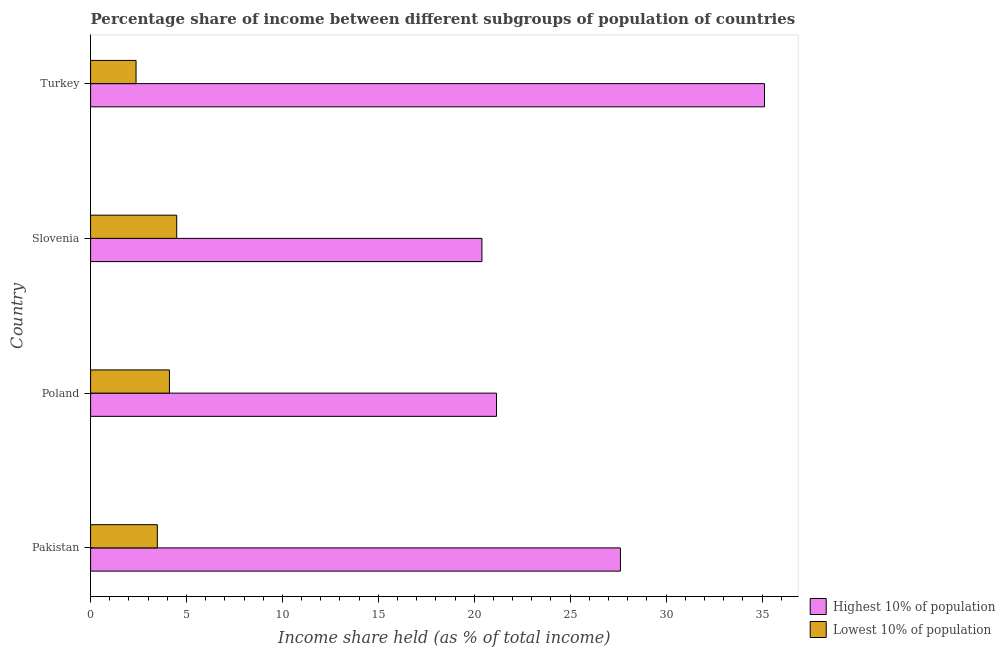How many different coloured bars are there?
Your response must be concise. 2. How many groups of bars are there?
Provide a succinct answer. 4. Are the number of bars per tick equal to the number of legend labels?
Provide a succinct answer. Yes. Are the number of bars on each tick of the Y-axis equal?
Your answer should be very brief. Yes. What is the label of the 1st group of bars from the top?
Your answer should be compact. Turkey. What is the income share held by highest 10% of the population in Slovenia?
Provide a short and direct response. 20.4. Across all countries, what is the maximum income share held by lowest 10% of the population?
Your answer should be very brief. 4.49. Across all countries, what is the minimum income share held by highest 10% of the population?
Give a very brief answer. 20.4. In which country was the income share held by highest 10% of the population minimum?
Your answer should be compact. Slovenia. What is the total income share held by lowest 10% of the population in the graph?
Your answer should be very brief. 14.45. What is the difference between the income share held by highest 10% of the population in Poland and that in Slovenia?
Your response must be concise. 0.76. What is the difference between the income share held by lowest 10% of the population in Slovenia and the income share held by highest 10% of the population in Poland?
Offer a terse response. -16.67. What is the average income share held by lowest 10% of the population per country?
Offer a terse response. 3.61. What is the difference between the income share held by lowest 10% of the population and income share held by highest 10% of the population in Slovenia?
Provide a succinct answer. -15.91. In how many countries, is the income share held by lowest 10% of the population greater than 26 %?
Make the answer very short. 0. What is the ratio of the income share held by highest 10% of the population in Pakistan to that in Slovenia?
Your answer should be very brief. 1.35. Is the income share held by highest 10% of the population in Poland less than that in Slovenia?
Provide a succinct answer. No. What is the difference between the highest and the second highest income share held by highest 10% of the population?
Keep it short and to the point. 7.51. What is the difference between the highest and the lowest income share held by highest 10% of the population?
Offer a terse response. 14.73. In how many countries, is the income share held by highest 10% of the population greater than the average income share held by highest 10% of the population taken over all countries?
Your response must be concise. 2. Is the sum of the income share held by highest 10% of the population in Slovenia and Turkey greater than the maximum income share held by lowest 10% of the population across all countries?
Offer a terse response. Yes. What does the 1st bar from the top in Poland represents?
Ensure brevity in your answer.  Lowest 10% of population. What does the 1st bar from the bottom in Turkey represents?
Give a very brief answer. Highest 10% of population. How many bars are there?
Keep it short and to the point. 8. Are all the bars in the graph horizontal?
Provide a succinct answer. Yes. How many countries are there in the graph?
Offer a very short reply. 4. Are the values on the major ticks of X-axis written in scientific E-notation?
Make the answer very short. No. Does the graph contain any zero values?
Give a very brief answer. No. Where does the legend appear in the graph?
Your response must be concise. Bottom right. How many legend labels are there?
Make the answer very short. 2. How are the legend labels stacked?
Your answer should be very brief. Vertical. What is the title of the graph?
Offer a terse response. Percentage share of income between different subgroups of population of countries. Does "Young" appear as one of the legend labels in the graph?
Offer a terse response. No. What is the label or title of the X-axis?
Keep it short and to the point. Income share held (as % of total income). What is the Income share held (as % of total income) in Highest 10% of population in Pakistan?
Offer a terse response. 27.62. What is the Income share held (as % of total income) in Lowest 10% of population in Pakistan?
Offer a very short reply. 3.48. What is the Income share held (as % of total income) in Highest 10% of population in Poland?
Ensure brevity in your answer.  21.16. What is the Income share held (as % of total income) of Lowest 10% of population in Poland?
Make the answer very short. 4.11. What is the Income share held (as % of total income) in Highest 10% of population in Slovenia?
Your answer should be very brief. 20.4. What is the Income share held (as % of total income) in Lowest 10% of population in Slovenia?
Give a very brief answer. 4.49. What is the Income share held (as % of total income) in Highest 10% of population in Turkey?
Ensure brevity in your answer.  35.13. What is the Income share held (as % of total income) of Lowest 10% of population in Turkey?
Ensure brevity in your answer.  2.37. Across all countries, what is the maximum Income share held (as % of total income) in Highest 10% of population?
Your response must be concise. 35.13. Across all countries, what is the maximum Income share held (as % of total income) in Lowest 10% of population?
Your response must be concise. 4.49. Across all countries, what is the minimum Income share held (as % of total income) in Highest 10% of population?
Offer a very short reply. 20.4. Across all countries, what is the minimum Income share held (as % of total income) of Lowest 10% of population?
Offer a very short reply. 2.37. What is the total Income share held (as % of total income) of Highest 10% of population in the graph?
Provide a short and direct response. 104.31. What is the total Income share held (as % of total income) in Lowest 10% of population in the graph?
Your response must be concise. 14.45. What is the difference between the Income share held (as % of total income) in Highest 10% of population in Pakistan and that in Poland?
Make the answer very short. 6.46. What is the difference between the Income share held (as % of total income) in Lowest 10% of population in Pakistan and that in Poland?
Provide a succinct answer. -0.63. What is the difference between the Income share held (as % of total income) in Highest 10% of population in Pakistan and that in Slovenia?
Provide a succinct answer. 7.22. What is the difference between the Income share held (as % of total income) in Lowest 10% of population in Pakistan and that in Slovenia?
Offer a terse response. -1.01. What is the difference between the Income share held (as % of total income) of Highest 10% of population in Pakistan and that in Turkey?
Your answer should be compact. -7.51. What is the difference between the Income share held (as % of total income) in Lowest 10% of population in Pakistan and that in Turkey?
Keep it short and to the point. 1.11. What is the difference between the Income share held (as % of total income) of Highest 10% of population in Poland and that in Slovenia?
Your response must be concise. 0.76. What is the difference between the Income share held (as % of total income) in Lowest 10% of population in Poland and that in Slovenia?
Make the answer very short. -0.38. What is the difference between the Income share held (as % of total income) in Highest 10% of population in Poland and that in Turkey?
Keep it short and to the point. -13.97. What is the difference between the Income share held (as % of total income) of Lowest 10% of population in Poland and that in Turkey?
Provide a succinct answer. 1.74. What is the difference between the Income share held (as % of total income) of Highest 10% of population in Slovenia and that in Turkey?
Ensure brevity in your answer.  -14.73. What is the difference between the Income share held (as % of total income) in Lowest 10% of population in Slovenia and that in Turkey?
Keep it short and to the point. 2.12. What is the difference between the Income share held (as % of total income) in Highest 10% of population in Pakistan and the Income share held (as % of total income) in Lowest 10% of population in Poland?
Your answer should be very brief. 23.51. What is the difference between the Income share held (as % of total income) in Highest 10% of population in Pakistan and the Income share held (as % of total income) in Lowest 10% of population in Slovenia?
Make the answer very short. 23.13. What is the difference between the Income share held (as % of total income) of Highest 10% of population in Pakistan and the Income share held (as % of total income) of Lowest 10% of population in Turkey?
Provide a short and direct response. 25.25. What is the difference between the Income share held (as % of total income) in Highest 10% of population in Poland and the Income share held (as % of total income) in Lowest 10% of population in Slovenia?
Your answer should be very brief. 16.67. What is the difference between the Income share held (as % of total income) of Highest 10% of population in Poland and the Income share held (as % of total income) of Lowest 10% of population in Turkey?
Your answer should be very brief. 18.79. What is the difference between the Income share held (as % of total income) of Highest 10% of population in Slovenia and the Income share held (as % of total income) of Lowest 10% of population in Turkey?
Your answer should be very brief. 18.03. What is the average Income share held (as % of total income) of Highest 10% of population per country?
Offer a very short reply. 26.08. What is the average Income share held (as % of total income) in Lowest 10% of population per country?
Offer a terse response. 3.61. What is the difference between the Income share held (as % of total income) in Highest 10% of population and Income share held (as % of total income) in Lowest 10% of population in Pakistan?
Your response must be concise. 24.14. What is the difference between the Income share held (as % of total income) of Highest 10% of population and Income share held (as % of total income) of Lowest 10% of population in Poland?
Your answer should be very brief. 17.05. What is the difference between the Income share held (as % of total income) in Highest 10% of population and Income share held (as % of total income) in Lowest 10% of population in Slovenia?
Keep it short and to the point. 15.91. What is the difference between the Income share held (as % of total income) in Highest 10% of population and Income share held (as % of total income) in Lowest 10% of population in Turkey?
Give a very brief answer. 32.76. What is the ratio of the Income share held (as % of total income) in Highest 10% of population in Pakistan to that in Poland?
Your response must be concise. 1.31. What is the ratio of the Income share held (as % of total income) in Lowest 10% of population in Pakistan to that in Poland?
Your answer should be very brief. 0.85. What is the ratio of the Income share held (as % of total income) in Highest 10% of population in Pakistan to that in Slovenia?
Provide a short and direct response. 1.35. What is the ratio of the Income share held (as % of total income) of Lowest 10% of population in Pakistan to that in Slovenia?
Provide a short and direct response. 0.78. What is the ratio of the Income share held (as % of total income) of Highest 10% of population in Pakistan to that in Turkey?
Provide a succinct answer. 0.79. What is the ratio of the Income share held (as % of total income) of Lowest 10% of population in Pakistan to that in Turkey?
Ensure brevity in your answer.  1.47. What is the ratio of the Income share held (as % of total income) in Highest 10% of population in Poland to that in Slovenia?
Make the answer very short. 1.04. What is the ratio of the Income share held (as % of total income) in Lowest 10% of population in Poland to that in Slovenia?
Keep it short and to the point. 0.92. What is the ratio of the Income share held (as % of total income) in Highest 10% of population in Poland to that in Turkey?
Give a very brief answer. 0.6. What is the ratio of the Income share held (as % of total income) of Lowest 10% of population in Poland to that in Turkey?
Give a very brief answer. 1.73. What is the ratio of the Income share held (as % of total income) in Highest 10% of population in Slovenia to that in Turkey?
Provide a succinct answer. 0.58. What is the ratio of the Income share held (as % of total income) of Lowest 10% of population in Slovenia to that in Turkey?
Your answer should be compact. 1.89. What is the difference between the highest and the second highest Income share held (as % of total income) of Highest 10% of population?
Keep it short and to the point. 7.51. What is the difference between the highest and the second highest Income share held (as % of total income) in Lowest 10% of population?
Offer a very short reply. 0.38. What is the difference between the highest and the lowest Income share held (as % of total income) of Highest 10% of population?
Keep it short and to the point. 14.73. What is the difference between the highest and the lowest Income share held (as % of total income) of Lowest 10% of population?
Provide a short and direct response. 2.12. 